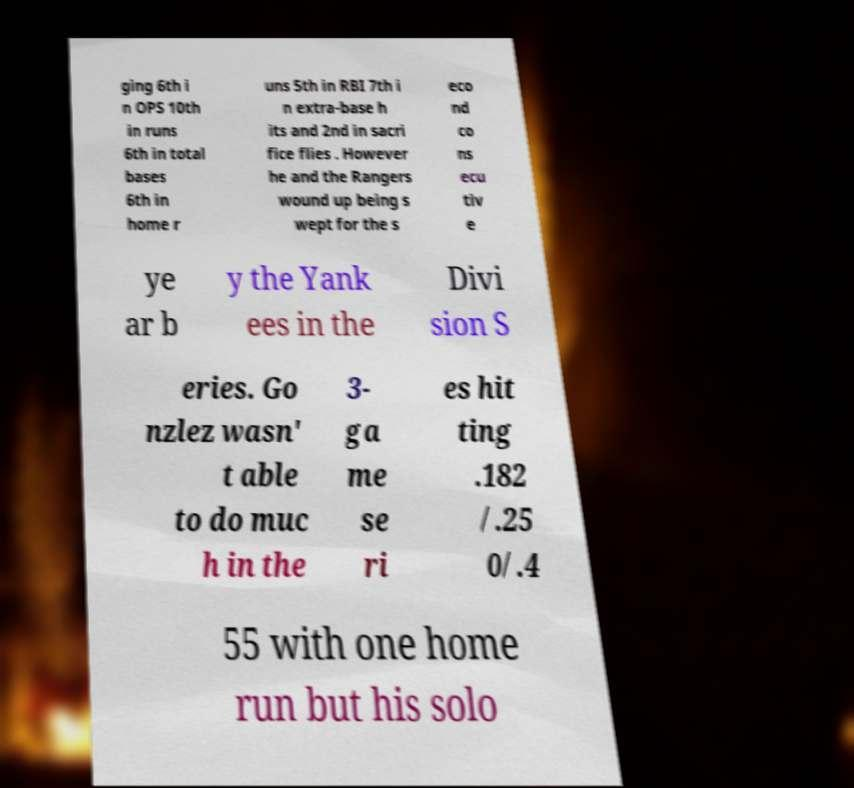Could you extract and type out the text from this image? ging 6th i n OPS 10th in runs 6th in total bases 6th in home r uns 5th in RBI 7th i n extra-base h its and 2nd in sacri fice flies . However he and the Rangers wound up being s wept for the s eco nd co ns ecu tiv e ye ar b y the Yank ees in the Divi sion S eries. Go nzlez wasn' t able to do muc h in the 3- ga me se ri es hit ting .182 /.25 0/.4 55 with one home run but his solo 